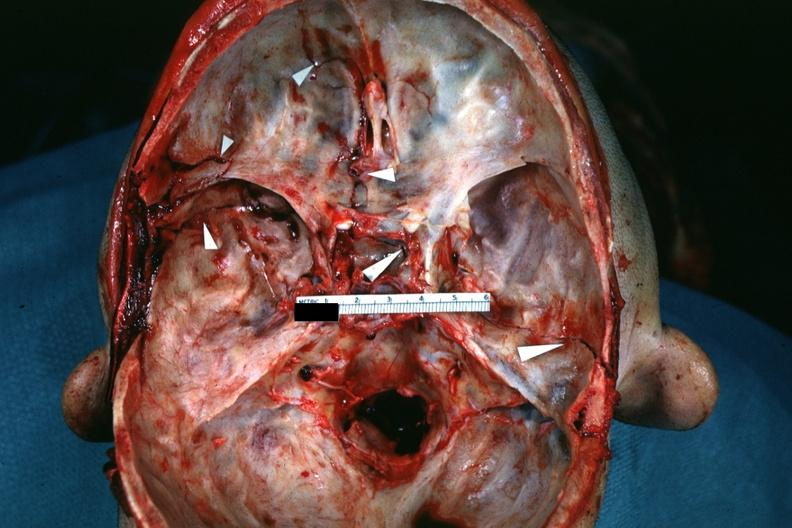s bone, calvarium present?
Answer the question using a single word or phrase. Yes 